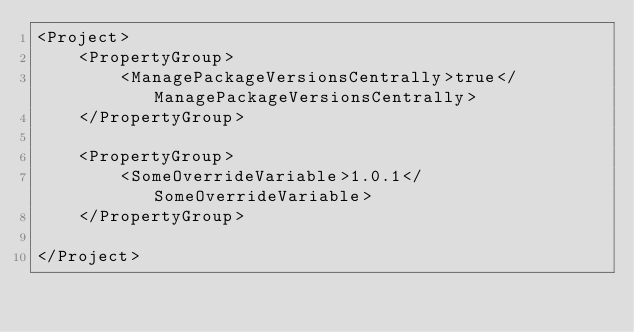<code> <loc_0><loc_0><loc_500><loc_500><_XML_><Project>
    <PropertyGroup>
        <ManagePackageVersionsCentrally>true</ManagePackageVersionsCentrally>
    </PropertyGroup>

    <PropertyGroup>
        <SomeOverrideVariable>1.0.1</SomeOverrideVariable>
    </PropertyGroup>
    
</Project></code> 